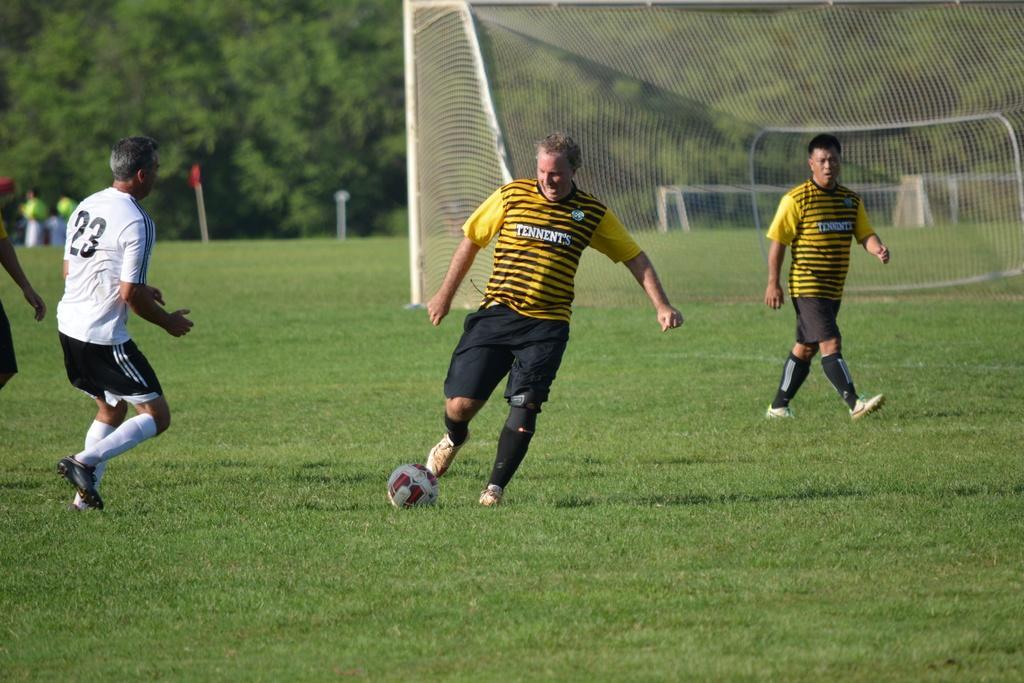Could you give a brief overview of what you see in this image? this picture shows four people playing football on the Greenfield and we see a net and few trees around 